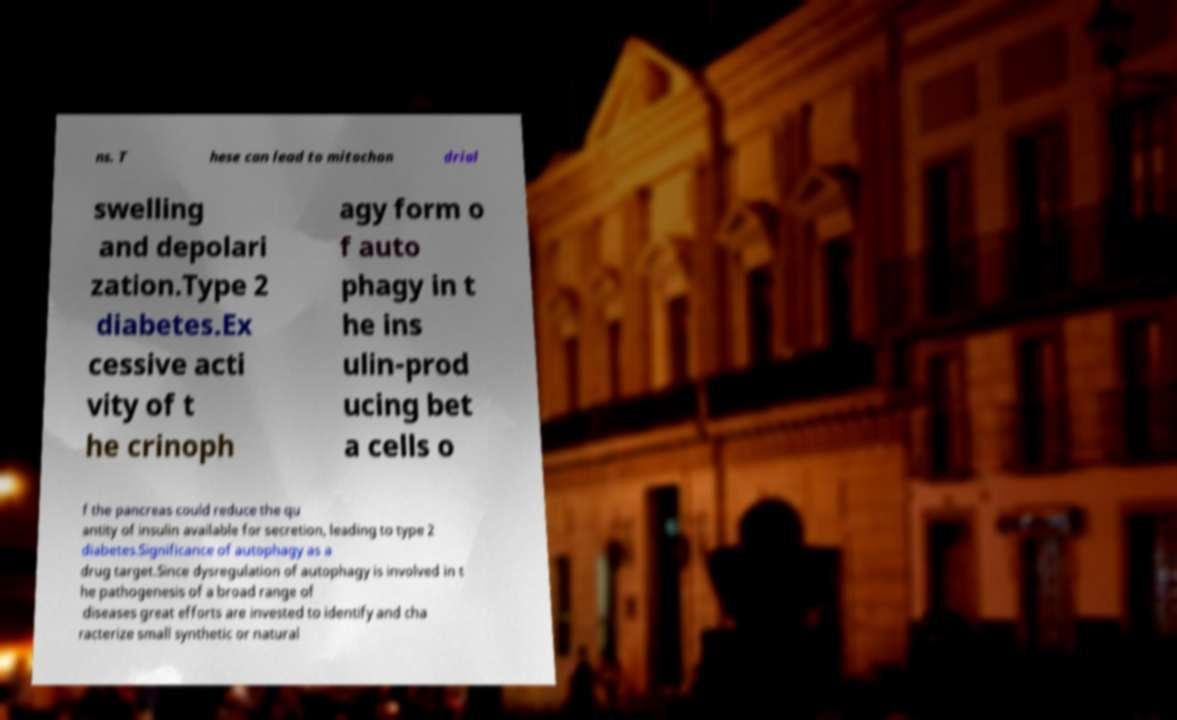Could you assist in decoding the text presented in this image and type it out clearly? ns. T hese can lead to mitochon drial swelling and depolari zation.Type 2 diabetes.Ex cessive acti vity of t he crinoph agy form o f auto phagy in t he ins ulin-prod ucing bet a cells o f the pancreas could reduce the qu antity of insulin available for secretion, leading to type 2 diabetes.Significance of autophagy as a drug target.Since dysregulation of autophagy is involved in t he pathogenesis of a broad range of diseases great efforts are invested to identify and cha racterize small synthetic or natural 